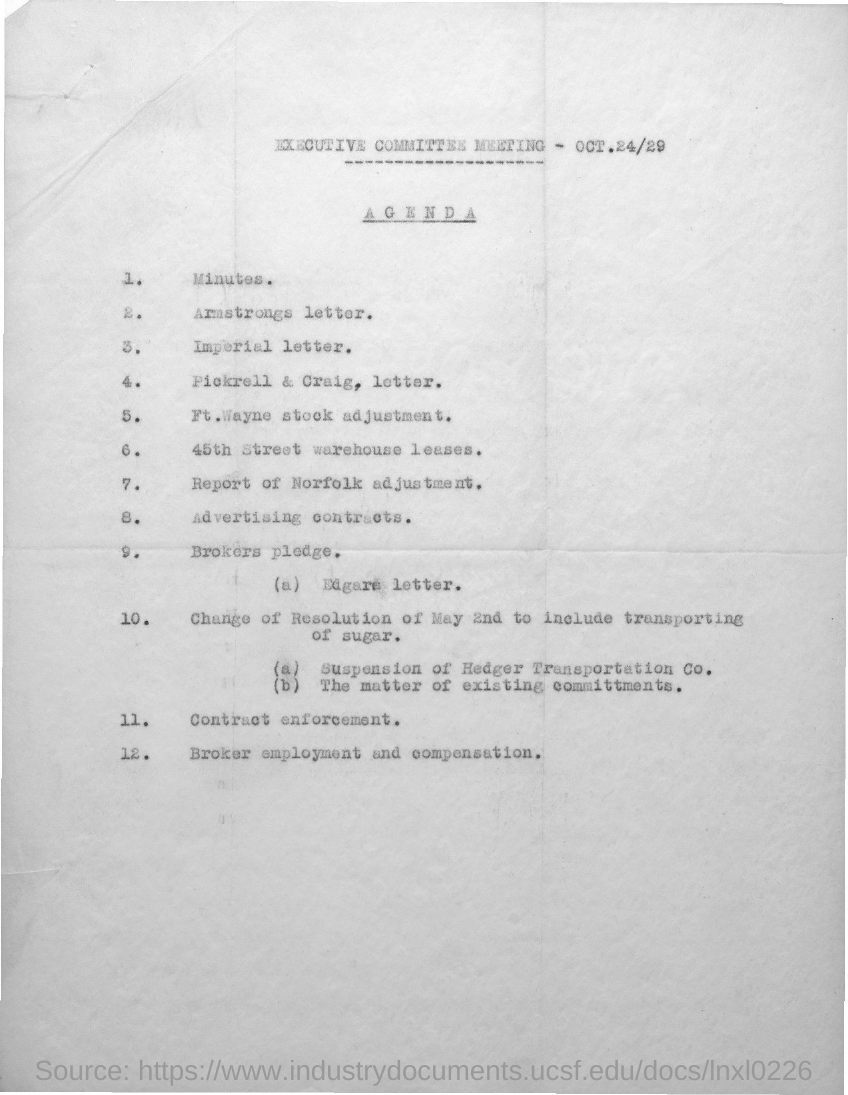Outline some significant characteristics in this image. The executive committee meeting will be held on OCT.24/29. 